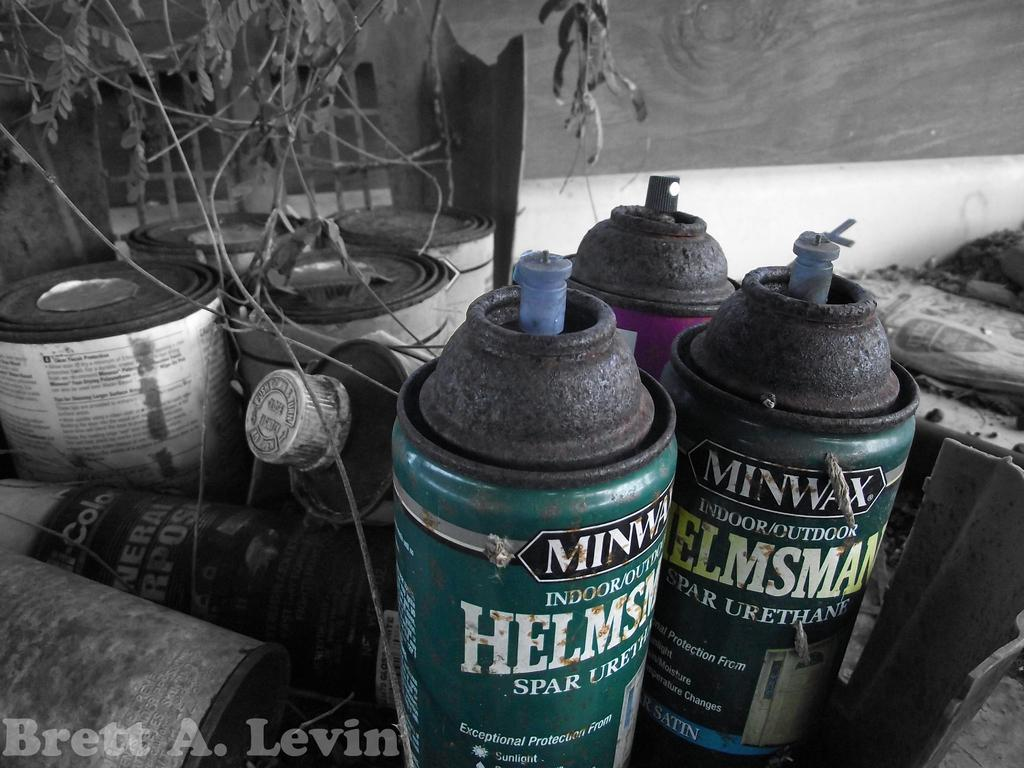<image>
Relay a brief, clear account of the picture shown. Brett A. Levin's name is superimposed on the picture of spray cans. 